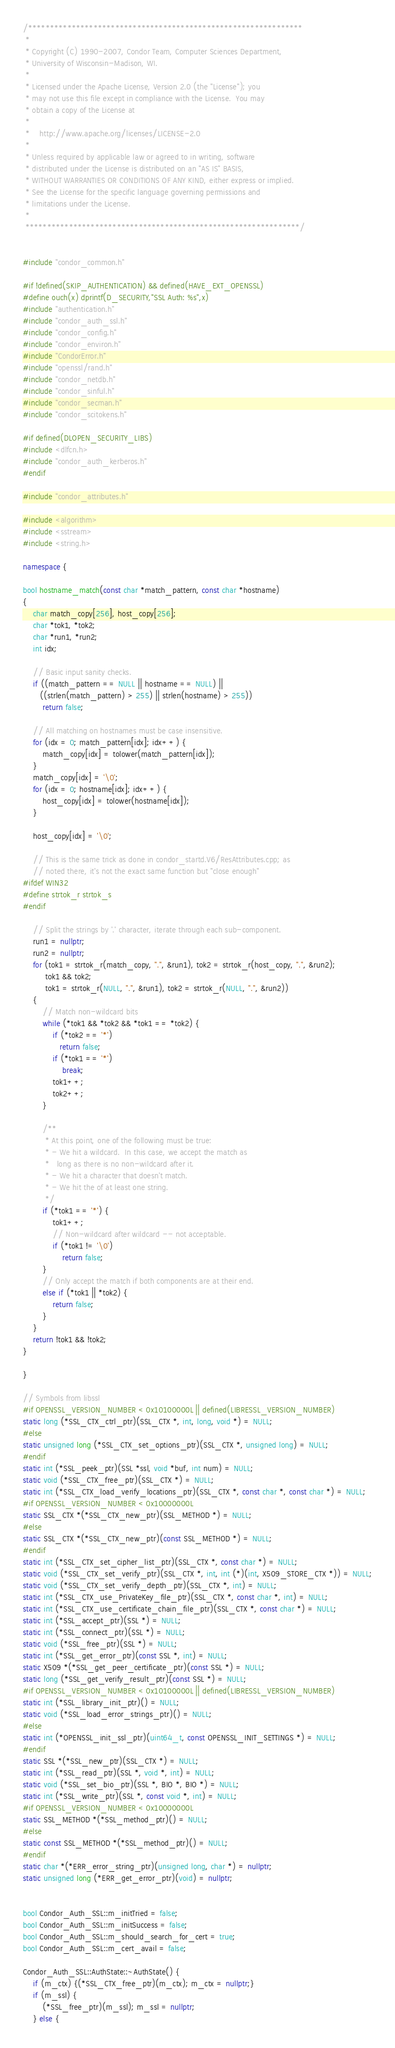Convert code to text. <code><loc_0><loc_0><loc_500><loc_500><_C++_>/***************************************************************
 *
 * Copyright (C) 1990-2007, Condor Team, Computer Sciences Department,
 * University of Wisconsin-Madison, WI.
 * 
 * Licensed under the Apache License, Version 2.0 (the "License"); you
 * may not use this file except in compliance with the License.  You may
 * obtain a copy of the License at
 * 
 *    http://www.apache.org/licenses/LICENSE-2.0
 * 
 * Unless required by applicable law or agreed to in writing, software
 * distributed under the License is distributed on an "AS IS" BASIS,
 * WITHOUT WARRANTIES OR CONDITIONS OF ANY KIND, either express or implied.
 * See the License for the specific language governing permissions and
 * limitations under the License.
 *
 ***************************************************************/


#include "condor_common.h"

#if !defined(SKIP_AUTHENTICATION) && defined(HAVE_EXT_OPENSSL)
#define ouch(x) dprintf(D_SECURITY,"SSL Auth: %s",x)
#include "authentication.h"
#include "condor_auth_ssl.h"
#include "condor_config.h"
#include "condor_environ.h"
#include "CondorError.h"
#include "openssl/rand.h"
#include "condor_netdb.h"
#include "condor_sinful.h"
#include "condor_secman.h"
#include "condor_scitokens.h"

#if defined(DLOPEN_SECURITY_LIBS)
#include <dlfcn.h>
#include "condor_auth_kerberos.h"
#endif

#include "condor_attributes.h"

#include <algorithm>
#include <sstream>
#include <string.h>

namespace {

bool hostname_match(const char *match_pattern, const char *hostname)
{
    char match_copy[256], host_copy[256];
    char *tok1, *tok2;
    char *run1, *run2;
    int idx;

    // Basic input sanity checks.
    if ((match_pattern == NULL || hostname == NULL) ||
       ((strlen(match_pattern) > 255) || strlen(hostname) > 255))
        return false;

    // All matching on hostnames must be case insensitive.
    for (idx = 0; match_pattern[idx]; idx++) {
        match_copy[idx] = tolower(match_pattern[idx]);
    }
    match_copy[idx] = '\0';
    for (idx = 0; hostname[idx]; idx++) {
        host_copy[idx] = tolower(hostname[idx]);
    }

    host_copy[idx] = '\0';

	// This is the same trick as done in condor_startd.V6/ResAttributes.cpp; as
	// noted there, it's not the exact same function but "close enough"
#ifdef WIN32
#define strtok_r strtok_s
#endif

    // Split the strings by '.' character, iterate through each sub-component.
    run1 = nullptr;
    run2 = nullptr;
    for (tok1 = strtok_r(match_copy, ".", &run1), tok2 = strtok_r(host_copy, ".", &run2);
         tok1 && tok2;
         tok1 = strtok_r(NULL, ".", &run1), tok2 = strtok_r(NULL, ".", &run2))
    {
        // Match non-wildcard bits
        while (*tok1 && *tok2 && *tok1 == *tok2) {
            if (*tok2 == '*')
               return false;
            if (*tok1 == '*')
                break;
            tok1++;
            tok2++;
        }

        /**
         * At this point, one of the following must be true:
         * - We hit a wildcard.  In this case, we accept the match as
         *   long as there is no non-wildcard after it.
         * - We hit a character that doesn't match.
         * - We hit the of at least one string.
         */
        if (*tok1 == '*') {
            tok1++;
            // Non-wildcard after wildcard -- not acceptable.
            if (*tok1 != '\0')
                return false;
        }
        // Only accept the match if both components are at their end.
        else if (*tok1 || *tok2) {
            return false;
        }
    }
    return !tok1 && !tok2;
}

}

// Symbols from libssl
#if OPENSSL_VERSION_NUMBER < 0x10100000L || defined(LIBRESSL_VERSION_NUMBER)
static long (*SSL_CTX_ctrl_ptr)(SSL_CTX *, int, long, void *) = NULL;
#else
static unsigned long (*SSL_CTX_set_options_ptr)(SSL_CTX *, unsigned long) = NULL;
#endif
static int (*SSL_peek_ptr)(SSL *ssl, void *buf, int num) = NULL;
static void (*SSL_CTX_free_ptr)(SSL_CTX *) = NULL;
static int (*SSL_CTX_load_verify_locations_ptr)(SSL_CTX *, const char *, const char *) = NULL;
#if OPENSSL_VERSION_NUMBER < 0x10000000L
static SSL_CTX *(*SSL_CTX_new_ptr)(SSL_METHOD *) = NULL;
#else
static SSL_CTX *(*SSL_CTX_new_ptr)(const SSL_METHOD *) = NULL;
#endif
static int (*SSL_CTX_set_cipher_list_ptr)(SSL_CTX *, const char *) = NULL;
static void (*SSL_CTX_set_verify_ptr)(SSL_CTX *, int, int (*)(int, X509_STORE_CTX *)) = NULL;
static void (*SSL_CTX_set_verify_depth_ptr)(SSL_CTX *, int) = NULL;
static int (*SSL_CTX_use_PrivateKey_file_ptr)(SSL_CTX *, const char *, int) = NULL;
static int (*SSL_CTX_use_certificate_chain_file_ptr)(SSL_CTX *, const char *) = NULL;
static int (*SSL_accept_ptr)(SSL *) = NULL;
static int (*SSL_connect_ptr)(SSL *) = NULL;
static void (*SSL_free_ptr)(SSL *) = NULL;
static int (*SSL_get_error_ptr)(const SSL *, int) = NULL;
static X509 *(*SSL_get_peer_certificate_ptr)(const SSL *) = NULL;
static long (*SSL_get_verify_result_ptr)(const SSL *) = NULL;
#if OPENSSL_VERSION_NUMBER < 0x10100000L || defined(LIBRESSL_VERSION_NUMBER)
static int (*SSL_library_init_ptr)() = NULL;
static void (*SSL_load_error_strings_ptr)() = NULL;
#else
static int (*OPENSSL_init_ssl_ptr)(uint64_t, const OPENSSL_INIT_SETTINGS *) = NULL;
#endif
static SSL *(*SSL_new_ptr)(SSL_CTX *) = NULL;
static int (*SSL_read_ptr)(SSL *, void *, int) = NULL;
static void (*SSL_set_bio_ptr)(SSL *, BIO *, BIO *) = NULL;
static int (*SSL_write_ptr)(SSL *, const void *, int) = NULL;
#if OPENSSL_VERSION_NUMBER < 0x10000000L
static SSL_METHOD *(*SSL_method_ptr)() = NULL;
#else
static const SSL_METHOD *(*SSL_method_ptr)() = NULL;
#endif
static char *(*ERR_error_string_ptr)(unsigned long, char *) = nullptr;
static unsigned long (*ERR_get_error_ptr)(void) = nullptr;


bool Condor_Auth_SSL::m_initTried = false;
bool Condor_Auth_SSL::m_initSuccess = false;
bool Condor_Auth_SSL::m_should_search_for_cert = true;
bool Condor_Auth_SSL::m_cert_avail = false;

Condor_Auth_SSL::AuthState::~AuthState() {
	if (m_ctx) {(*SSL_CTX_free_ptr)(m_ctx); m_ctx = nullptr;}
	if (m_ssl) {
		(*SSL_free_ptr)(m_ssl); m_ssl = nullptr;
	} else {</code> 